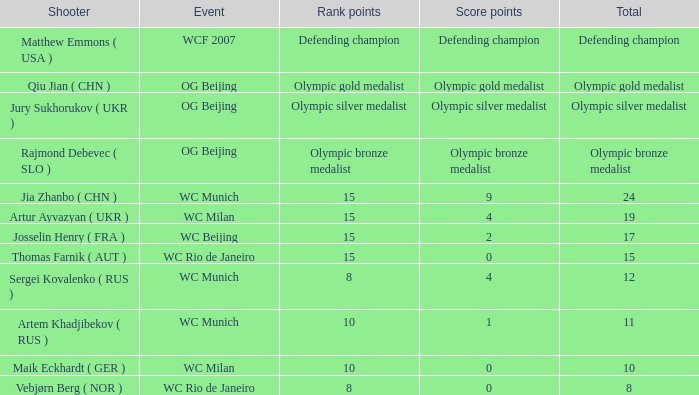What is the total score points for an olympic bronze medalist? Olympic bronze medalist. 